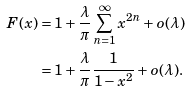<formula> <loc_0><loc_0><loc_500><loc_500>F ( x ) & = 1 + \frac { \lambda } { \pi } \sum _ { n = 1 } ^ { \infty } x ^ { 2 n } + o ( \lambda ) \\ & = 1 + \frac { \lambda } { \pi } \frac { 1 } { 1 - x ^ { 2 } } + o ( \lambda ) .</formula> 